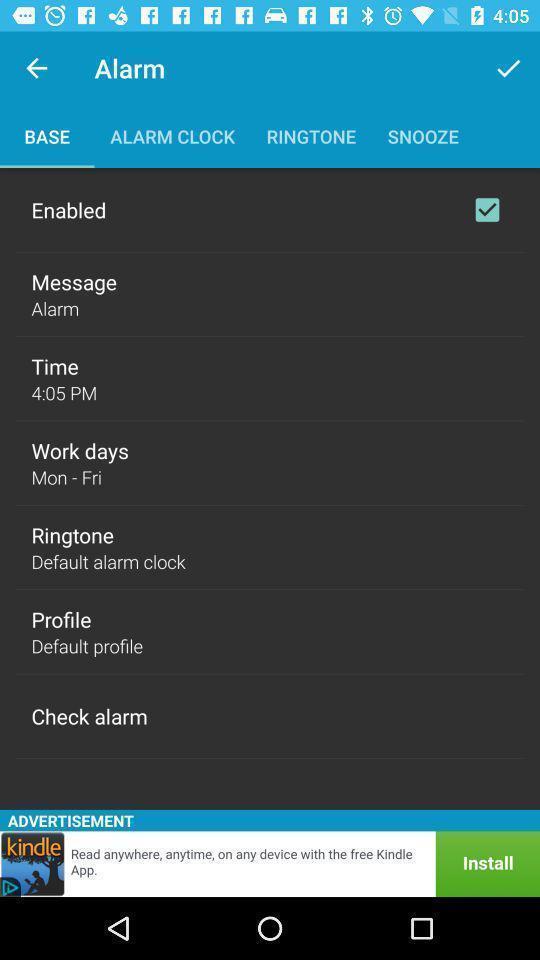Give me a narrative description of this picture. Screen showing basic alarm settings. 